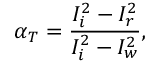<formula> <loc_0><loc_0><loc_500><loc_500>\alpha _ { T } = \frac { I _ { i } ^ { 2 } - I _ { r } ^ { 2 } } { I _ { i } ^ { 2 } - I _ { w } ^ { 2 } } ,</formula> 